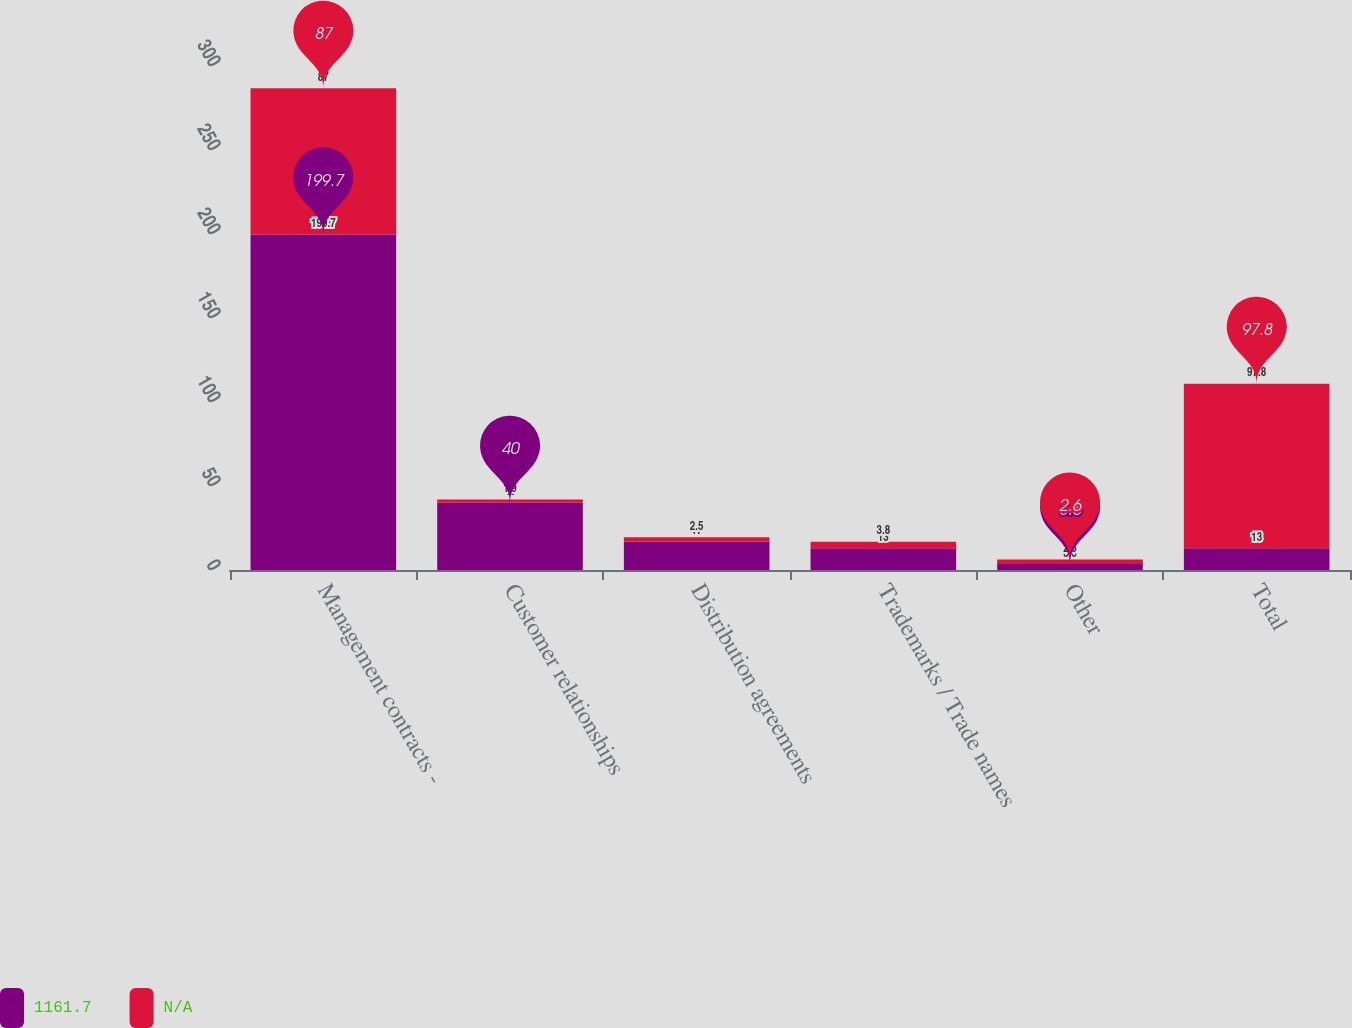Convert chart. <chart><loc_0><loc_0><loc_500><loc_500><stacked_bar_chart><ecel><fcel>Management contracts -<fcel>Customer relationships<fcel>Distribution agreements<fcel>Trademarks / Trade names<fcel>Other<fcel>Total<nl><fcel>1161.7<fcel>199.7<fcel>40<fcel>17<fcel>13<fcel>3.6<fcel>13<nl><fcel>nan<fcel>87<fcel>1.9<fcel>2.5<fcel>3.8<fcel>2.6<fcel>97.8<nl></chart> 